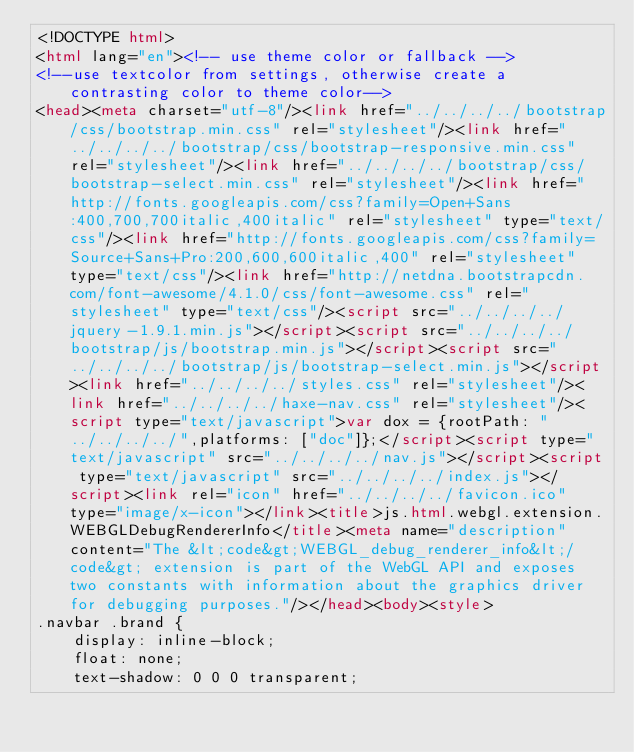Convert code to text. <code><loc_0><loc_0><loc_500><loc_500><_HTML_><!DOCTYPE html>
<html lang="en"><!-- use theme color or fallback -->
<!--use textcolor from settings, otherwise create a contrasting color to theme color-->
<head><meta charset="utf-8"/><link href="../../../../bootstrap/css/bootstrap.min.css" rel="stylesheet"/><link href="../../../../bootstrap/css/bootstrap-responsive.min.css" rel="stylesheet"/><link href="../../../../bootstrap/css/bootstrap-select.min.css" rel="stylesheet"/><link href="http://fonts.googleapis.com/css?family=Open+Sans:400,700,700italic,400italic" rel="stylesheet" type="text/css"/><link href="http://fonts.googleapis.com/css?family=Source+Sans+Pro:200,600,600italic,400" rel="stylesheet" type="text/css"/><link href="http://netdna.bootstrapcdn.com/font-awesome/4.1.0/css/font-awesome.css" rel="stylesheet" type="text/css"/><script src="../../../../jquery-1.9.1.min.js"></script><script src="../../../../bootstrap/js/bootstrap.min.js"></script><script src="../../../../bootstrap/js/bootstrap-select.min.js"></script><link href="../../../../styles.css" rel="stylesheet"/><link href="../../../../haxe-nav.css" rel="stylesheet"/><script type="text/javascript">var dox = {rootPath: "../../../../",platforms: ["doc"]};</script><script type="text/javascript" src="../../../../nav.js"></script><script type="text/javascript" src="../../../../index.js"></script><link rel="icon" href="../../../../favicon.ico" type="image/x-icon"></link><title>js.html.webgl.extension.WEBGLDebugRendererInfo</title><meta name="description" content="The &lt;code&gt;WEBGL_debug_renderer_info&lt;/code&gt; extension is part of the WebGL API and exposes two constants with information about the graphics driver for debugging purposes."/></head><body><style>
.navbar .brand {
	display: inline-block;
	float: none;
	text-shadow: 0 0 0 transparent;</code> 